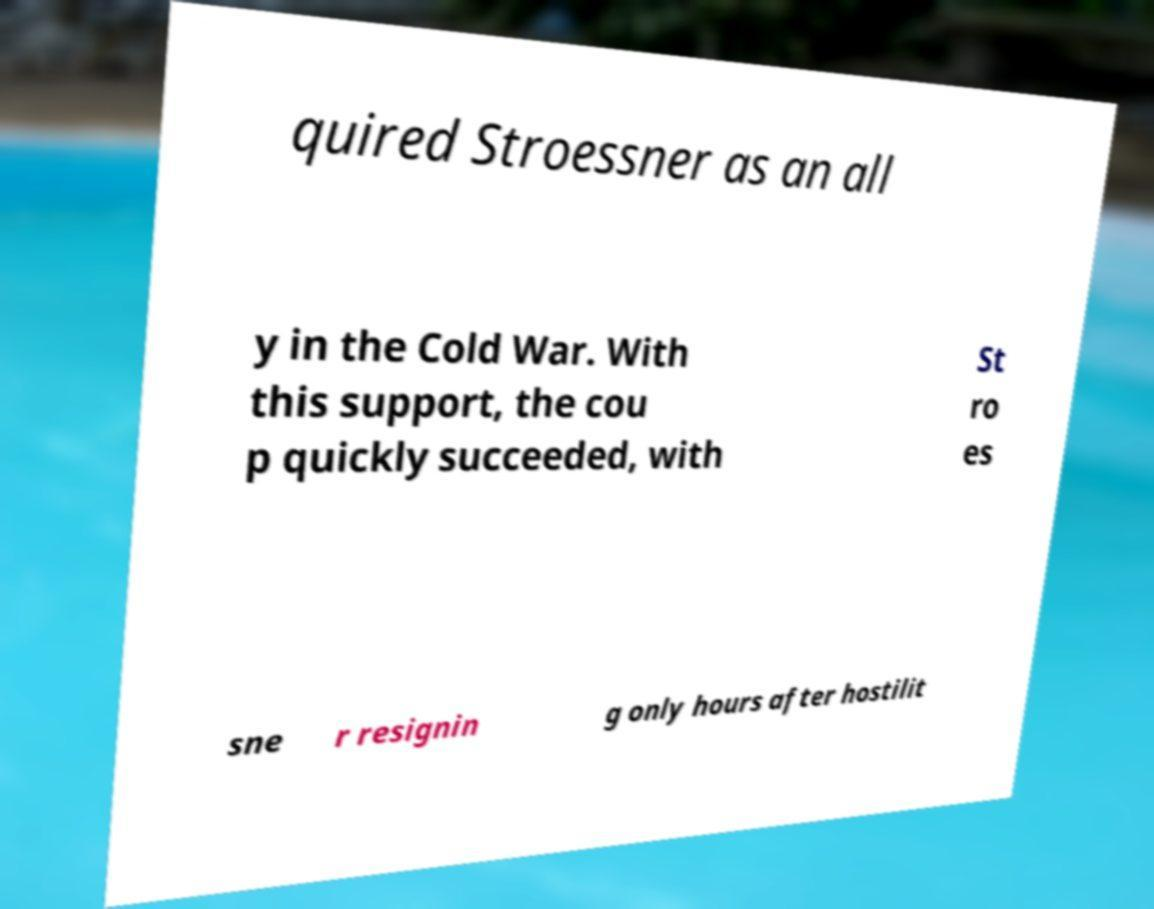Please identify and transcribe the text found in this image. quired Stroessner as an all y in the Cold War. With this support, the cou p quickly succeeded, with St ro es sne r resignin g only hours after hostilit 